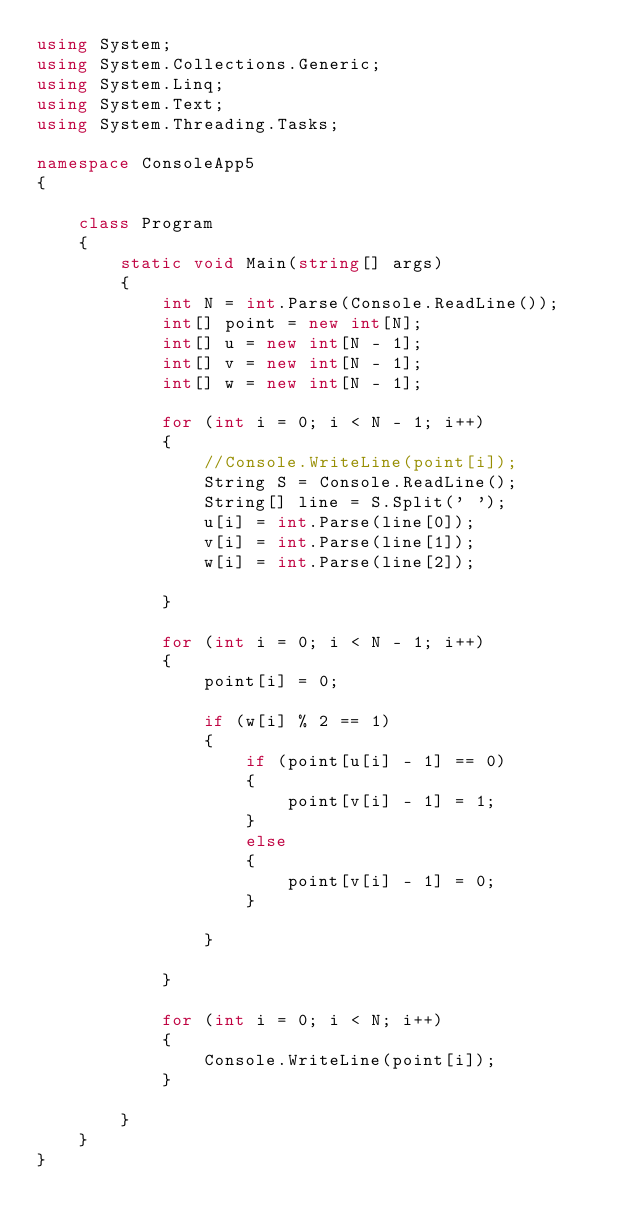<code> <loc_0><loc_0><loc_500><loc_500><_C#_>using System;
using System.Collections.Generic;
using System.Linq;
using System.Text;
using System.Threading.Tasks;

namespace ConsoleApp5
{

    class Program
    {
        static void Main(string[] args)
        {
            int N = int.Parse(Console.ReadLine());
            int[] point = new int[N];
            int[] u = new int[N - 1];
            int[] v = new int[N - 1];
            int[] w = new int[N - 1];

            for (int i = 0; i < N - 1; i++)
            {
                //Console.WriteLine(point[i]);
                String S = Console.ReadLine();
                String[] line = S.Split(' ');
                u[i] = int.Parse(line[0]);
                v[i] = int.Parse(line[1]);
                w[i] = int.Parse(line[2]);

            }

            for (int i = 0; i < N - 1; i++)
            {
                point[i] = 0;

                if (w[i] % 2 == 1)
                {
                    if (point[u[i] - 1] == 0)
                    {
                        point[v[i] - 1] = 1;
                    }
                    else
                    {
                        point[v[i] - 1] = 0;
                    }

                }

            }

            for (int i = 0; i < N; i++)
            {
                Console.WriteLine(point[i]);
            }

        }
    }
}</code> 